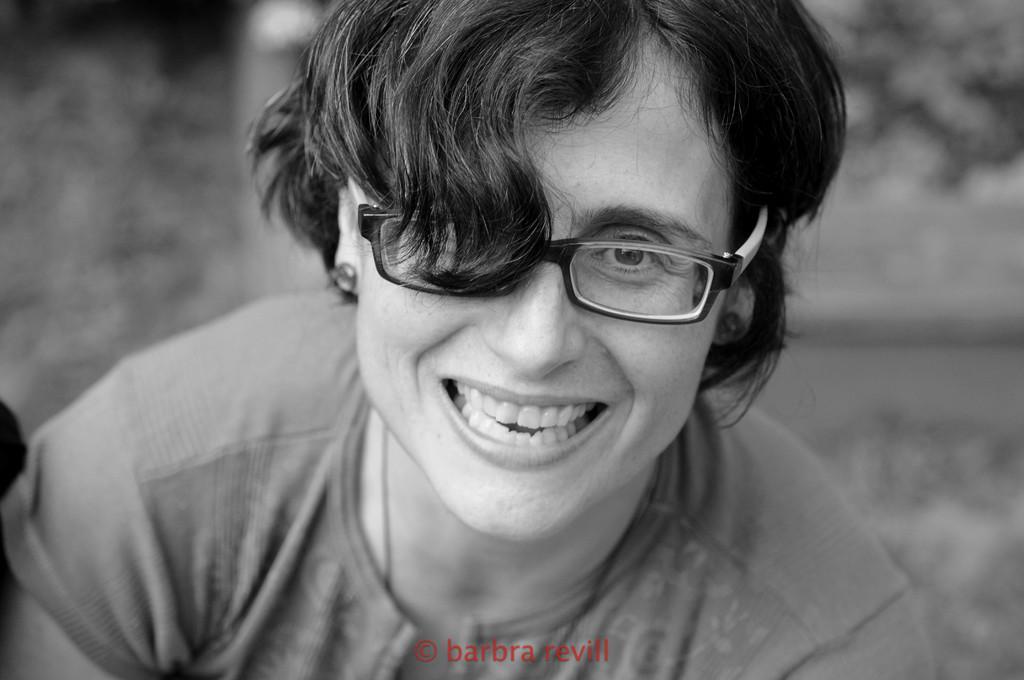What is the person in the image doing? The person is sitting in the image. What expression does the person have? The person is smiling. Can you describe the background of the image? The background of the image is blurry. What is present at the bottom of the image? There is text at the bottom of the image. What type of bear can be seen attacking the person in the image? There is no bear present in the image, nor is there any indication of an attack. 